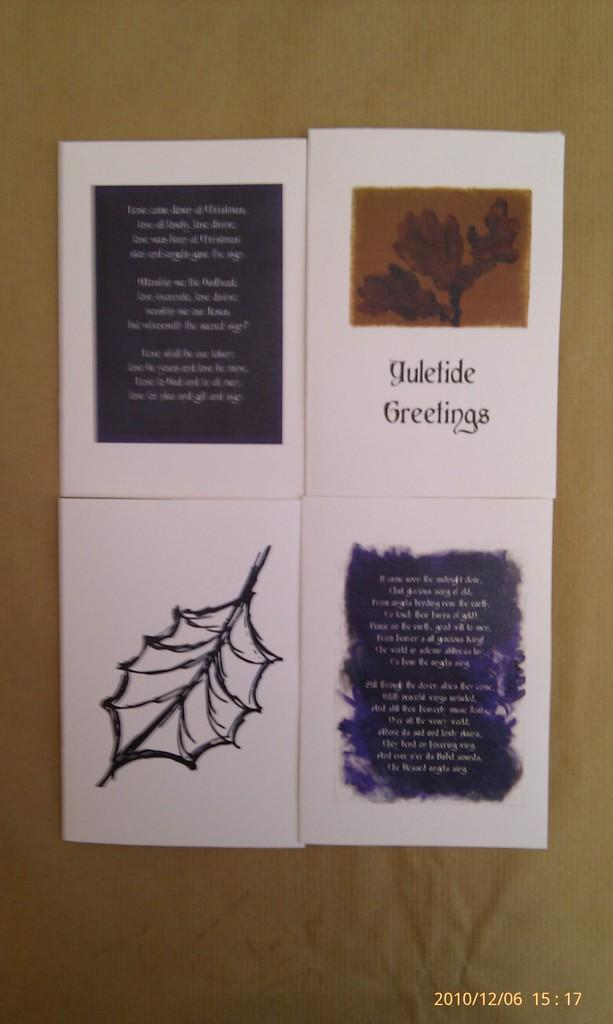Provide a one-sentence caption for the provided image. A photograph of Yuletide Greetings cards was taken on 12/06/2010. 